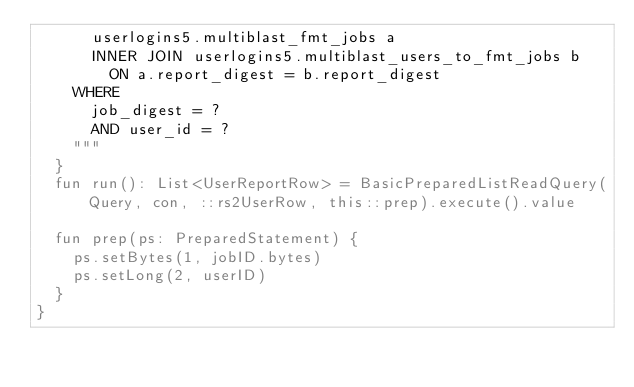<code> <loc_0><loc_0><loc_500><loc_500><_Kotlin_>      userlogins5.multiblast_fmt_jobs a
      INNER JOIN userlogins5.multiblast_users_to_fmt_jobs b
        ON a.report_digest = b.report_digest
    WHERE
      job_digest = ?
      AND user_id = ?
    """
  }
  fun run(): List<UserReportRow> = BasicPreparedListReadQuery(Query, con, ::rs2UserRow, this::prep).execute().value

  fun prep(ps: PreparedStatement) {
    ps.setBytes(1, jobID.bytes)
    ps.setLong(2, userID)
  }
}
</code> 